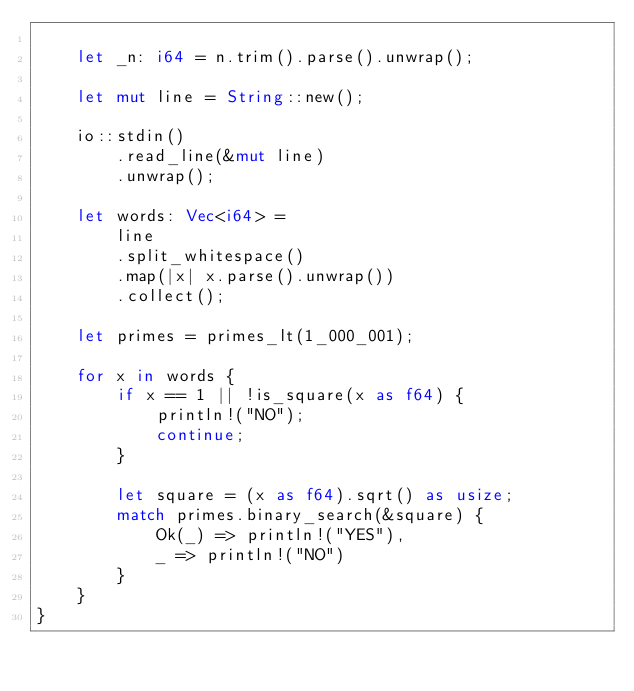Convert code to text. <code><loc_0><loc_0><loc_500><loc_500><_Rust_>
    let _n: i64 = n.trim().parse().unwrap();

    let mut line = String::new();

    io::stdin()
        .read_line(&mut line)
        .unwrap();

    let words: Vec<i64> =
        line
        .split_whitespace()
        .map(|x| x.parse().unwrap())
        .collect();

    let primes = primes_lt(1_000_001);

    for x in words {
        if x == 1 || !is_square(x as f64) {
            println!("NO");
            continue;
        }

        let square = (x as f64).sqrt() as usize;
        match primes.binary_search(&square) {
            Ok(_) => println!("YES"),
            _ => println!("NO")
        }
    }
}

</code> 